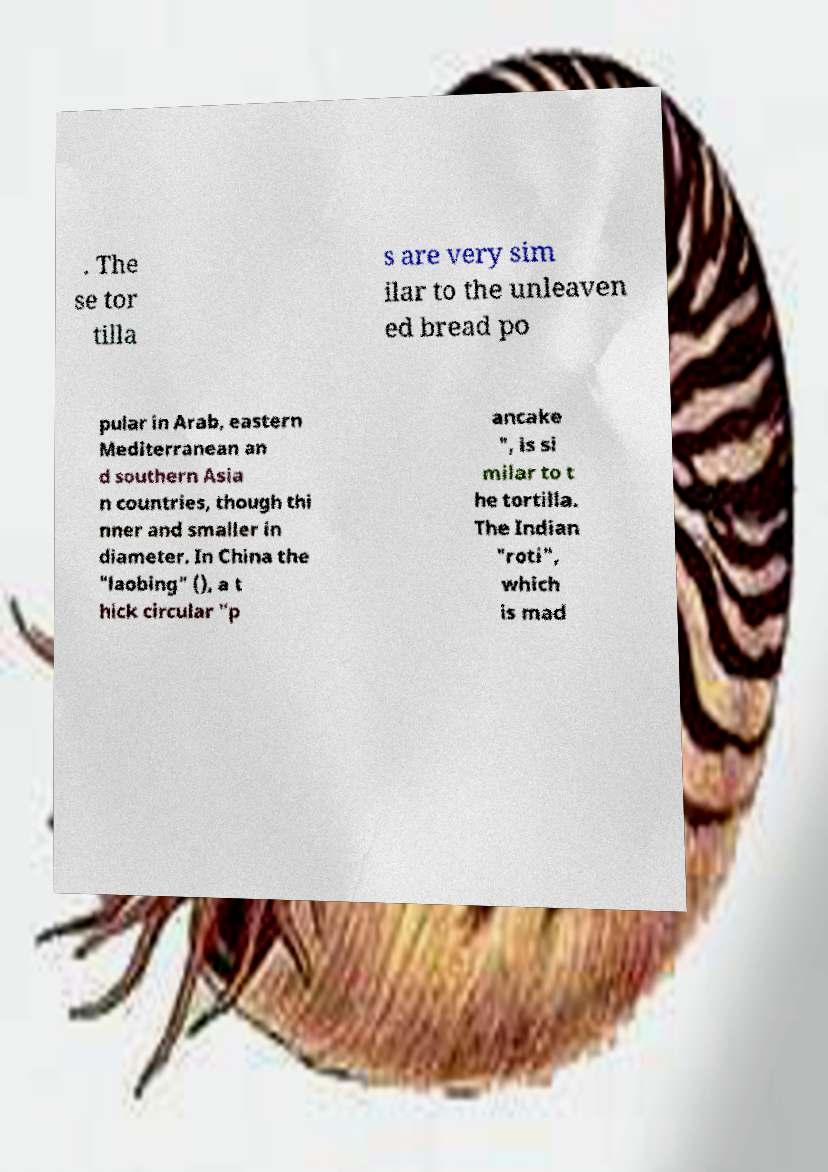Could you extract and type out the text from this image? . The se tor tilla s are very sim ilar to the unleaven ed bread po pular in Arab, eastern Mediterranean an d southern Asia n countries, though thi nner and smaller in diameter. In China the "laobing" (), a t hick circular "p ancake ", is si milar to t he tortilla. The Indian "roti", which is mad 